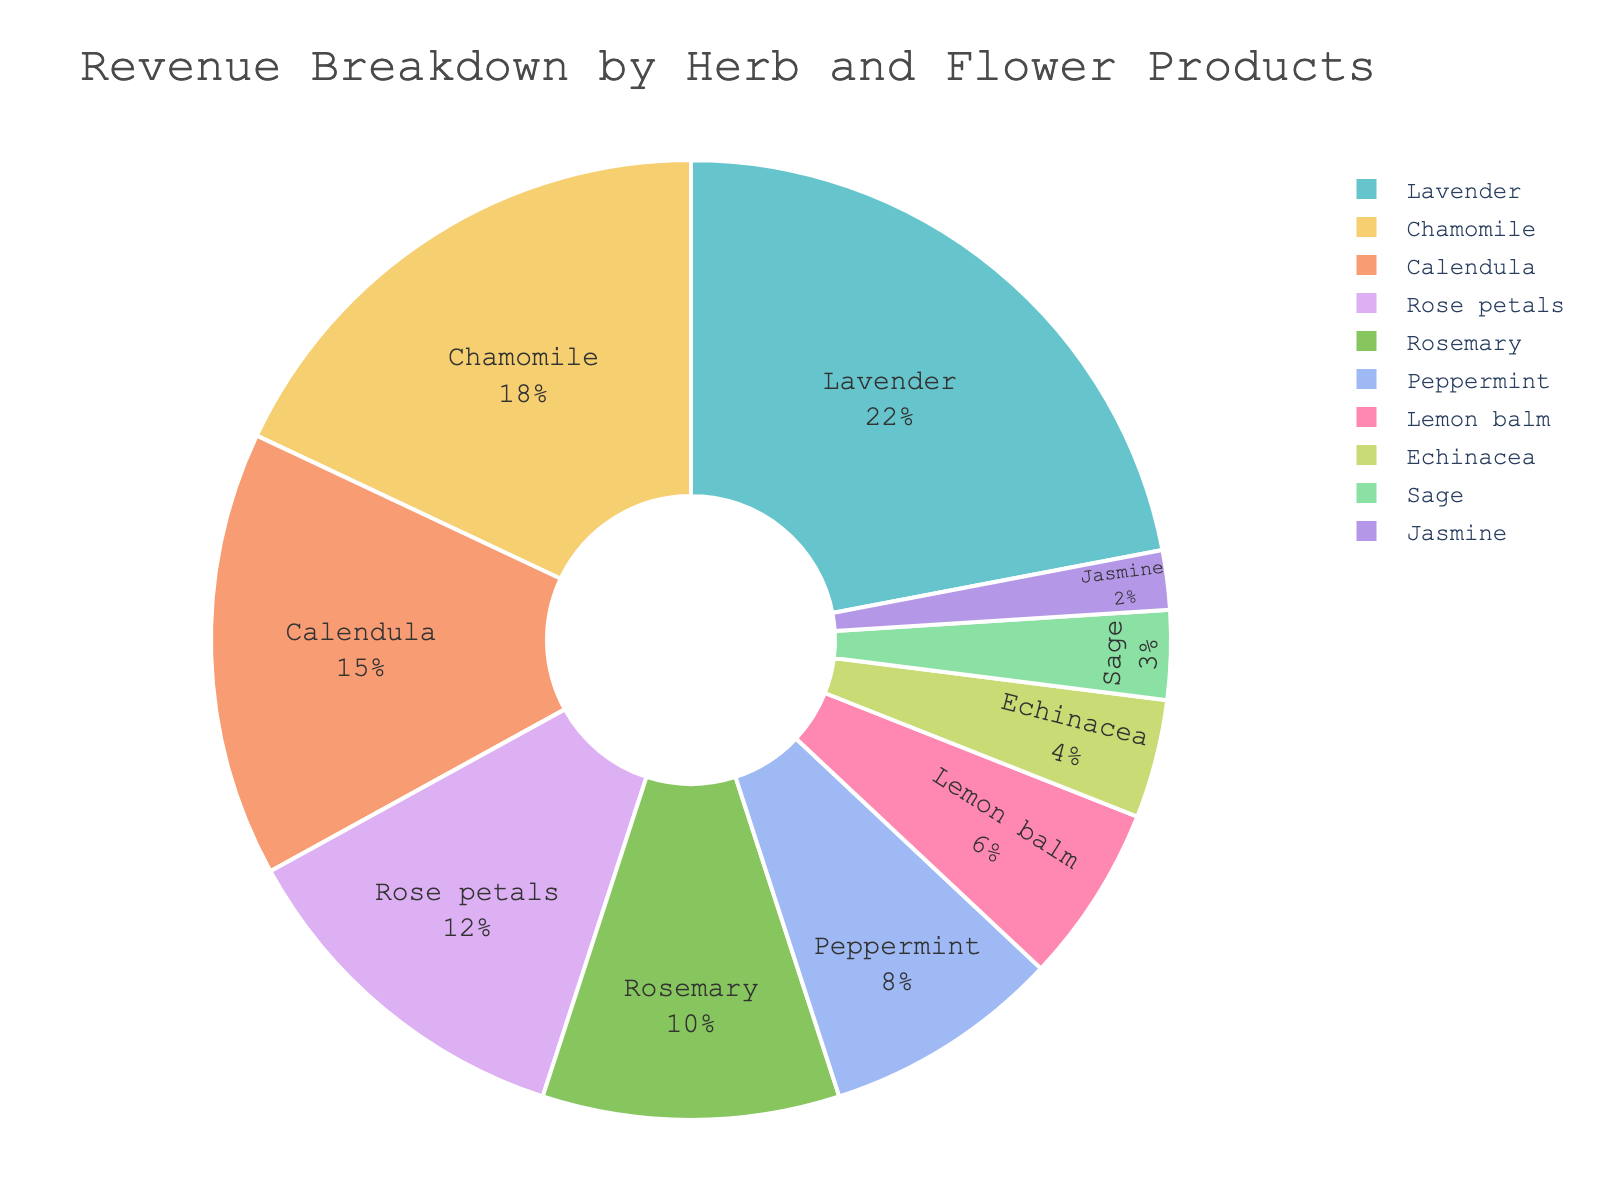Which product generates the highest revenue? By looking at the pie chart, the largest slice represents Lavender, indicating it has the highest percentage of revenue.
Answer: Lavender What is the combined revenue percentage for Chamomile and Calendula? From the pie chart, Chamomile comprises 18% and Calendula 15%. Adding these together, 18% + 15% = 33%.
Answer: 33% How much larger is the revenue percentage of Rose petals compared to Peppermint? Rose petals have a revenue percentage of 12%, while Peppermint has 8%. The difference is 12% - 8% = 4%.
Answer: 4% Which product has the smallest revenue percentage? The smallest slice in the pie chart represents Jasmine, which has a percentage of 2%.
Answer: Jasmine What is the total revenue percentage for all products that individually generate less than 10%? Summing percentages of products with less than 10%: Peppermint (8%), Lemon balm (6%), Echinacea (4%), Sage (3%), Jasmine (2%). Total is 8% + 6% + 4% + 3% + 2% = 23%.
Answer: 23% Which products together make up more than half of the total revenue? Adding the largest slices: Lavender (22%), Chamomile (18%), and Calendula (15%). Summing them equals 22% + 18% + 15% = 55%, which is more than half.
Answer: Lavender, Chamomile, Calendula Is the revenue percentage of Rosemary greater than the combined percentage of Sage and Jasmine? Rosemary has 10%, while Sage and Jasmine together make 3% + 2% = 5%. Comparing 10% and 5%, Rosemary's percentage is greater.
Answer: Yes What is the difference in revenue percentages between the top 2 products? The top 2 products are Lavender (22%) and Chamomile (18%). Their difference is 22% - 18% = 4%.
Answer: 4% Which three products contribute the least to the revenue? The smallest slices in the pie chart represent Jasmine (2%), Sage (3%), and Echinacea (4%).
Answer: Jasmine, Sage, Echinacea 